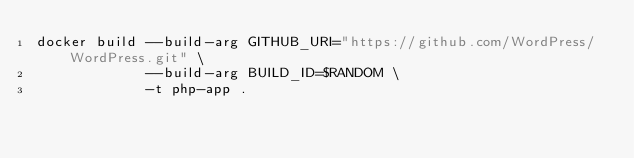Convert code to text. <code><loc_0><loc_0><loc_500><loc_500><_Bash_>docker build --build-arg GITHUB_URI="https://github.com/WordPress/WordPress.git" \
             --build-arg BUILD_ID=$RANDOM \
             -t php-app .

</code> 